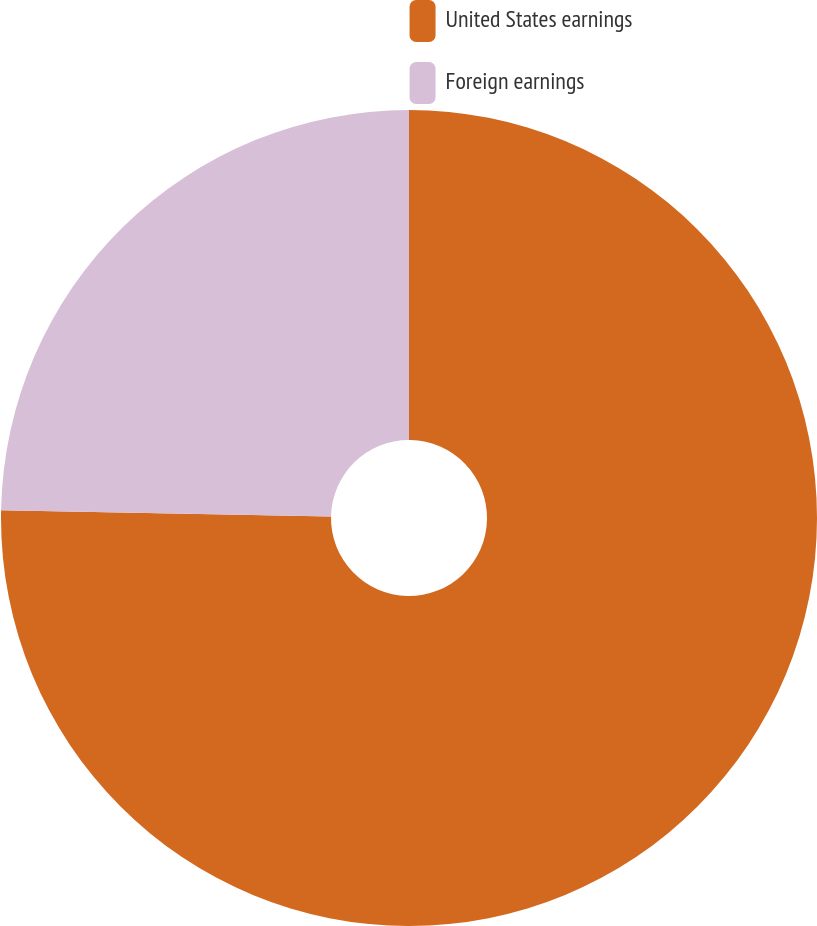Convert chart to OTSL. <chart><loc_0><loc_0><loc_500><loc_500><pie_chart><fcel>United States earnings<fcel>Foreign earnings<nl><fcel>75.3%<fcel>24.7%<nl></chart> 